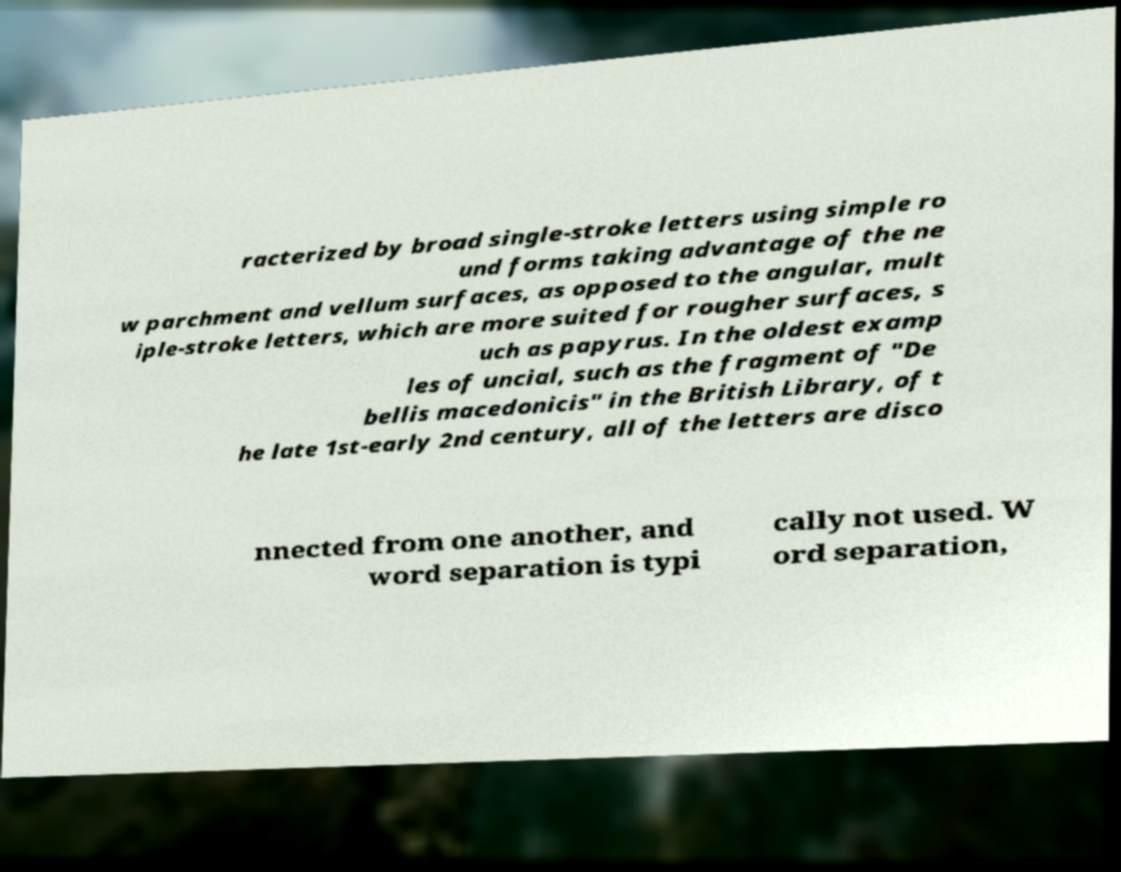Could you extract and type out the text from this image? racterized by broad single-stroke letters using simple ro und forms taking advantage of the ne w parchment and vellum surfaces, as opposed to the angular, mult iple-stroke letters, which are more suited for rougher surfaces, s uch as papyrus. In the oldest examp les of uncial, such as the fragment of "De bellis macedonicis" in the British Library, of t he late 1st-early 2nd century, all of the letters are disco nnected from one another, and word separation is typi cally not used. W ord separation, 